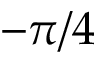Convert formula to latex. <formula><loc_0><loc_0><loc_500><loc_500>- \pi / 4</formula> 